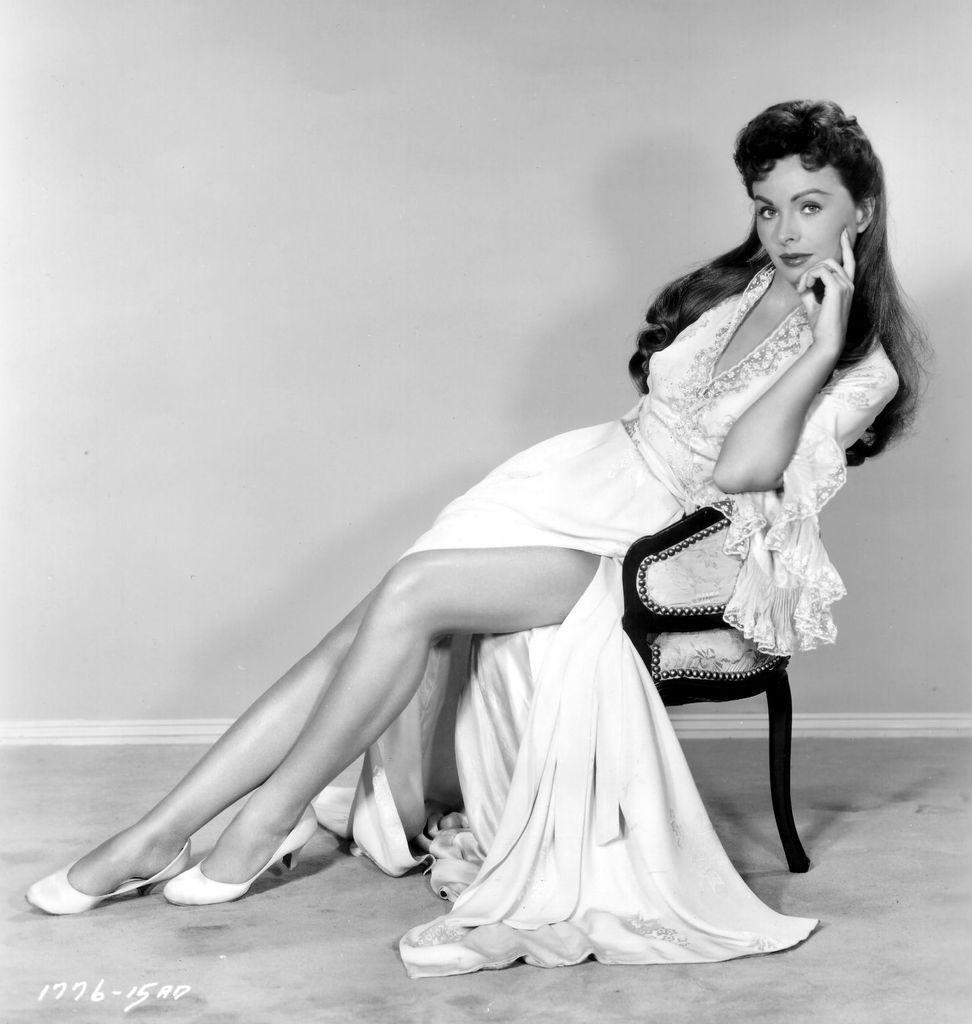How would you summarize this image in a sentence or two? This picture is in black and white. In the picture, there is a woman sitting on the chair. She is wearing a long frock. 